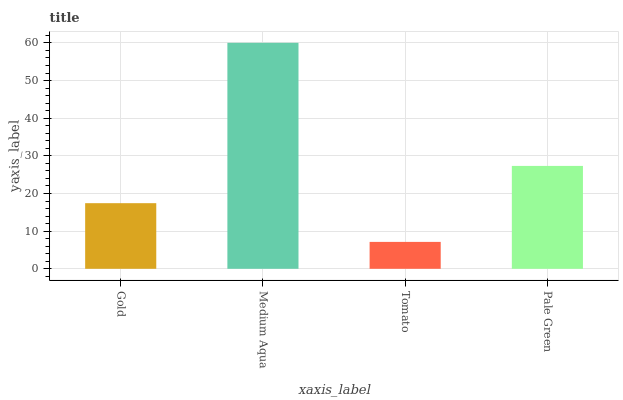Is Tomato the minimum?
Answer yes or no. Yes. Is Medium Aqua the maximum?
Answer yes or no. Yes. Is Medium Aqua the minimum?
Answer yes or no. No. Is Tomato the maximum?
Answer yes or no. No. Is Medium Aqua greater than Tomato?
Answer yes or no. Yes. Is Tomato less than Medium Aqua?
Answer yes or no. Yes. Is Tomato greater than Medium Aqua?
Answer yes or no. No. Is Medium Aqua less than Tomato?
Answer yes or no. No. Is Pale Green the high median?
Answer yes or no. Yes. Is Gold the low median?
Answer yes or no. Yes. Is Gold the high median?
Answer yes or no. No. Is Tomato the low median?
Answer yes or no. No. 